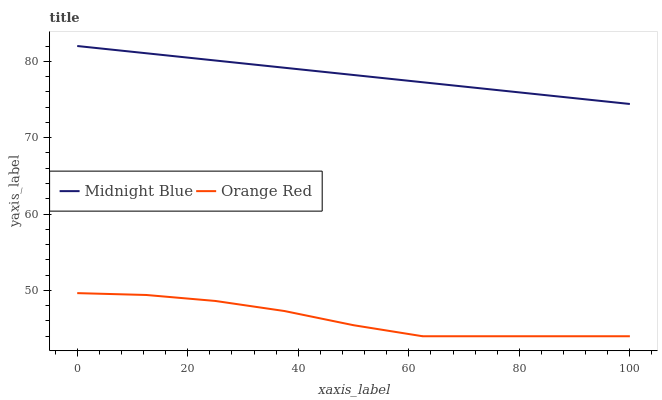Does Orange Red have the maximum area under the curve?
Answer yes or no. No. Is Orange Red the smoothest?
Answer yes or no. No. Does Orange Red have the highest value?
Answer yes or no. No. Is Orange Red less than Midnight Blue?
Answer yes or no. Yes. Is Midnight Blue greater than Orange Red?
Answer yes or no. Yes. Does Orange Red intersect Midnight Blue?
Answer yes or no. No. 